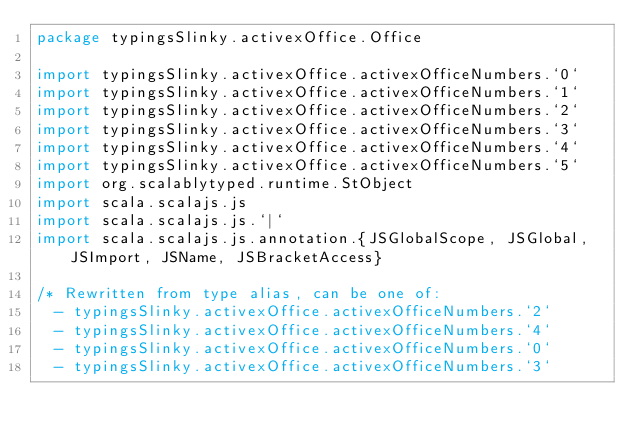<code> <loc_0><loc_0><loc_500><loc_500><_Scala_>package typingsSlinky.activexOffice.Office

import typingsSlinky.activexOffice.activexOfficeNumbers.`0`
import typingsSlinky.activexOffice.activexOfficeNumbers.`1`
import typingsSlinky.activexOffice.activexOfficeNumbers.`2`
import typingsSlinky.activexOffice.activexOfficeNumbers.`3`
import typingsSlinky.activexOffice.activexOfficeNumbers.`4`
import typingsSlinky.activexOffice.activexOfficeNumbers.`5`
import org.scalablytyped.runtime.StObject
import scala.scalajs.js
import scala.scalajs.js.`|`
import scala.scalajs.js.annotation.{JSGlobalScope, JSGlobal, JSImport, JSName, JSBracketAccess}

/* Rewritten from type alias, can be one of: 
  - typingsSlinky.activexOffice.activexOfficeNumbers.`2`
  - typingsSlinky.activexOffice.activexOfficeNumbers.`4`
  - typingsSlinky.activexOffice.activexOfficeNumbers.`0`
  - typingsSlinky.activexOffice.activexOfficeNumbers.`3`</code> 